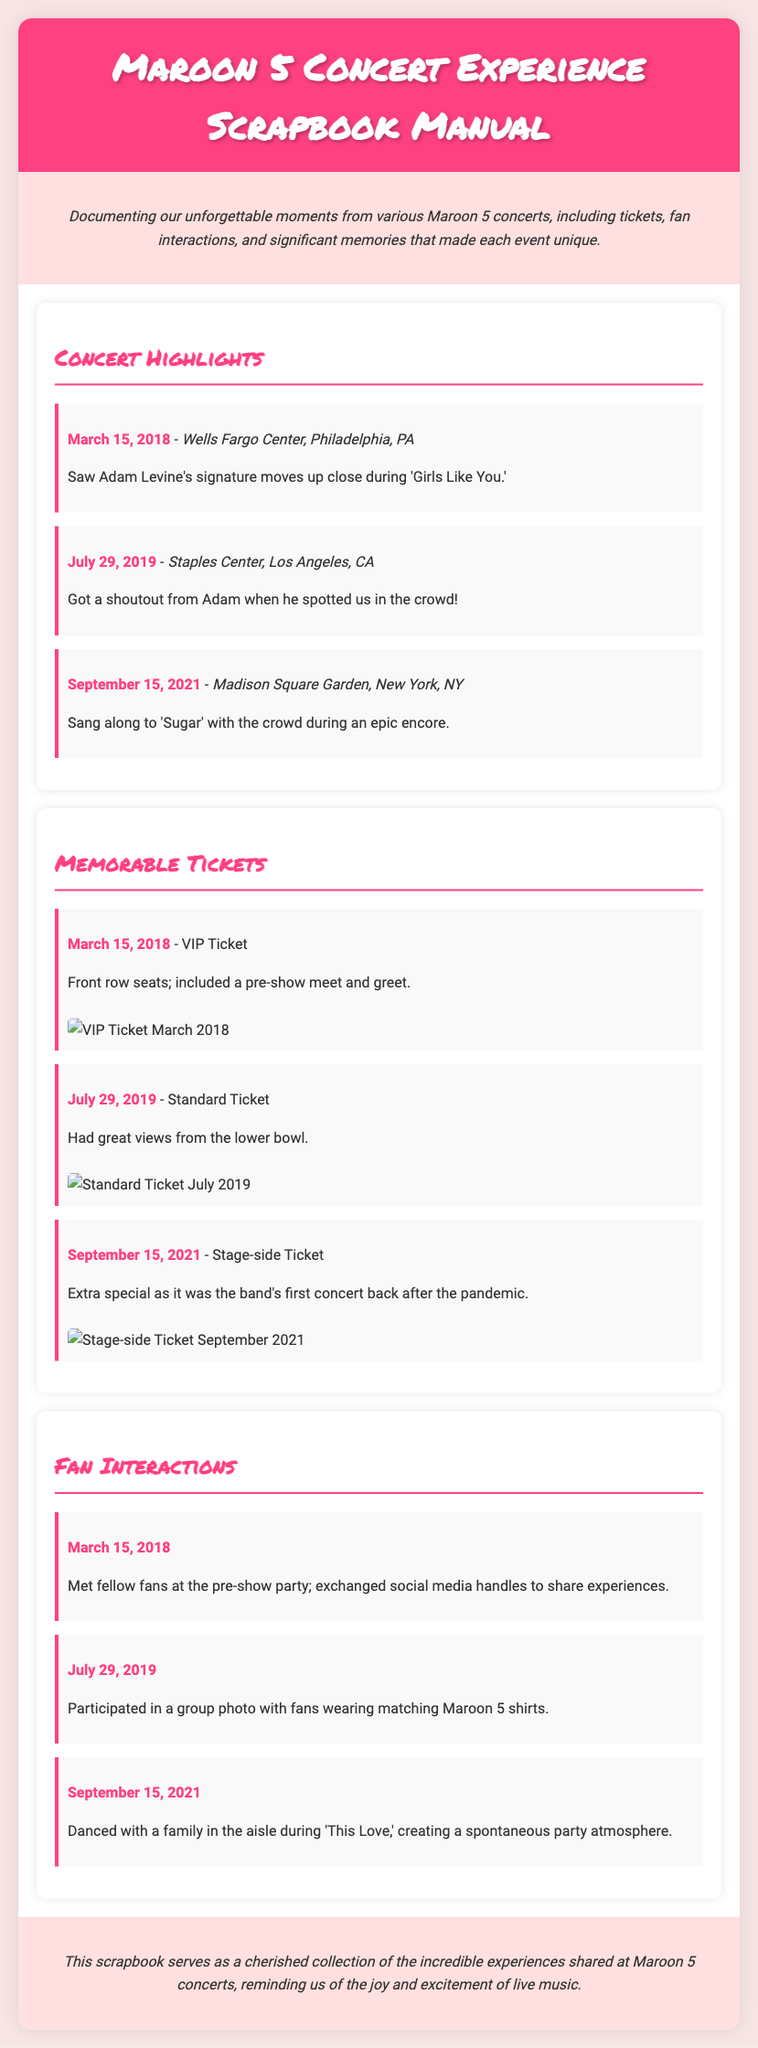what was the date of the concert at Wells Fargo Center? The date of the concert at Wells Fargo Center is explicitly mentioned in the highlights section as March 15, 2018.
Answer: March 15, 2018 how many concerts are mentioned in the scrapbook? The document lists three concerts under the concert highlights section.
Answer: Three which song did Adam Levine perform in Philadelphia? The specific song performed by Adam Levine mentioned for the March 15, 2018 concert in Philadelphia is 'Girls Like You.'
Answer: Girls Like You what type of ticket was used for the concert on July 29, 2019? The type of ticket for the July 29, 2019 concert is specified as a Standard Ticket in the memorable tickets section.
Answer: Standard Ticket what unique experience was highlighted for the September 15, 2021 concert? For the September 15, 2021 concert, it is highlighted as the band's first concert back after the pandemic, indicating its significance.
Answer: First concert back after the pandemic who did the fans meet at the pre-show party on March 15, 2018? The fans met fellow fans at the pre-show party on March 15, 2018, as mentioned in the fan interactions section.
Answer: Fellow fans how did Adam Levine acknowledge the fans on July 29, 2019? Adam Levine acknowledged the fans by giving a shoutout when he spotted them in the crowd on July 29, 2019.
Answer: Shoutout from Adam what was the mood during 'This Love' at the September 15, 2021 concert? The mood during 'This Love' involved spontaneous dancing with a family in the aisle, creating a party atmosphere.
Answer: Spontaneous party atmosphere 